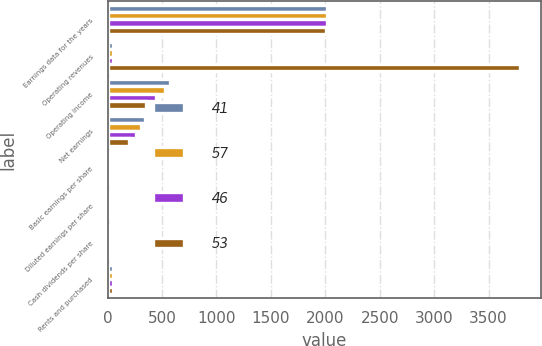<chart> <loc_0><loc_0><loc_500><loc_500><stacked_bar_chart><ecel><fcel>Earnings data for the years<fcel>Operating revenues<fcel>Operating income<fcel>Net earnings<fcel>Basic earnings per share<fcel>Diluted earnings per share<fcel>Cash dividends per share<fcel>Rents and purchased<nl><fcel>41<fcel>2013<fcel>49.2<fcel>577<fcel>342<fcel>2.92<fcel>2.87<fcel>0.45<fcel>50.2<nl><fcel>57<fcel>2012<fcel>49.2<fcel>530<fcel>310<fcel>2.64<fcel>2.59<fcel>0.71<fcel>49.2<nl><fcel>46<fcel>2011<fcel>49.2<fcel>444<fcel>257<fcel>2.16<fcel>2.11<fcel>0.52<fcel>46.9<nl><fcel>53<fcel>2010<fcel>3793<fcel>348<fcel>200<fcel>1.6<fcel>1.56<fcel>0.48<fcel>45.1<nl></chart> 